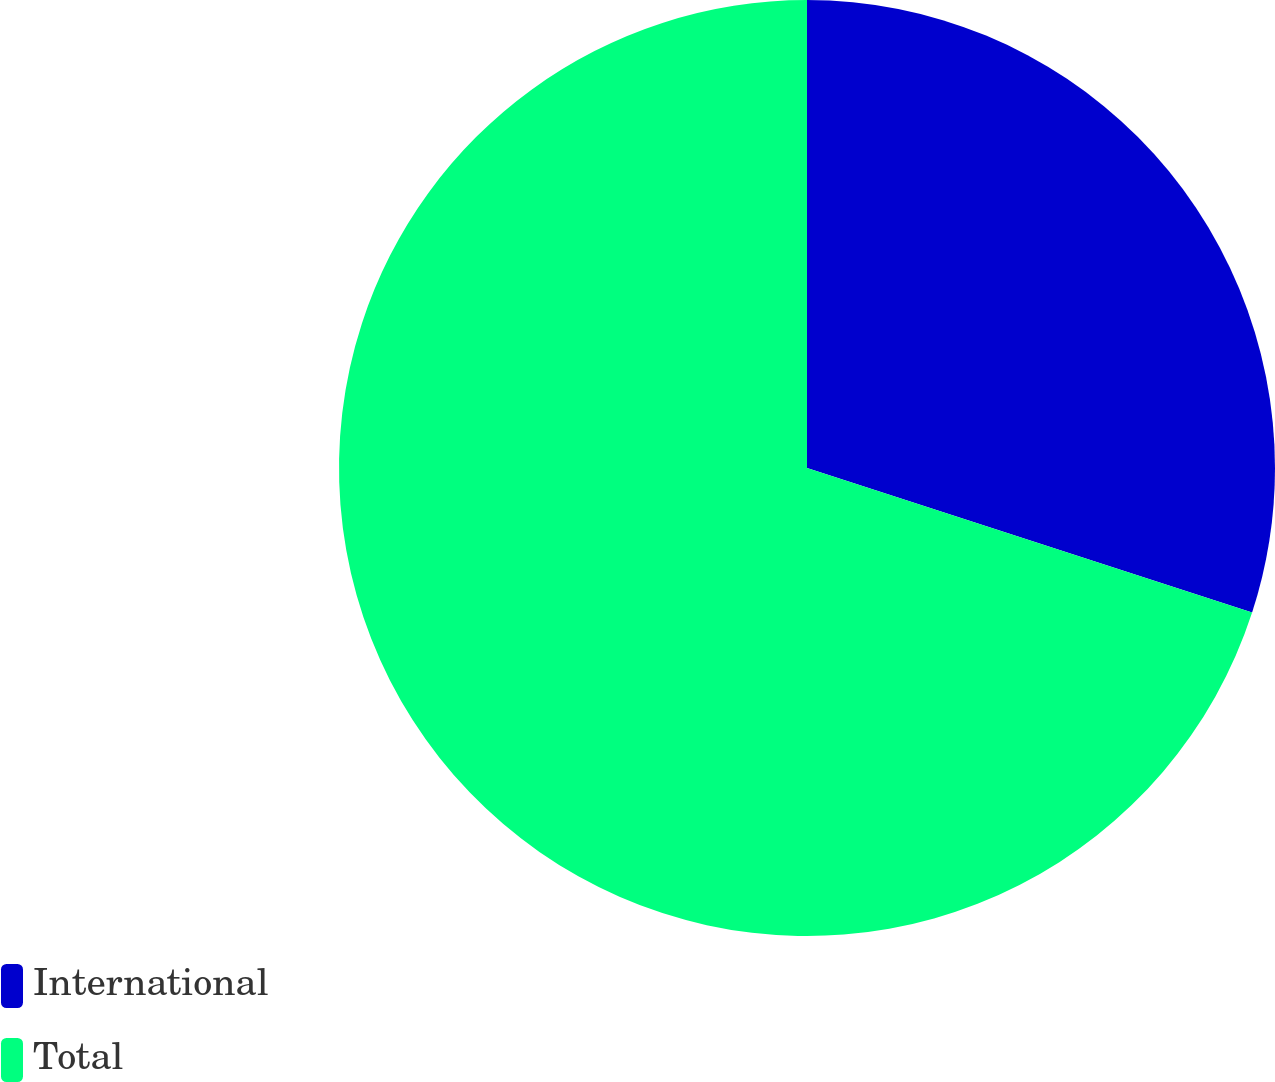Convert chart. <chart><loc_0><loc_0><loc_500><loc_500><pie_chart><fcel>International<fcel>Total<nl><fcel>30.0%<fcel>70.0%<nl></chart> 